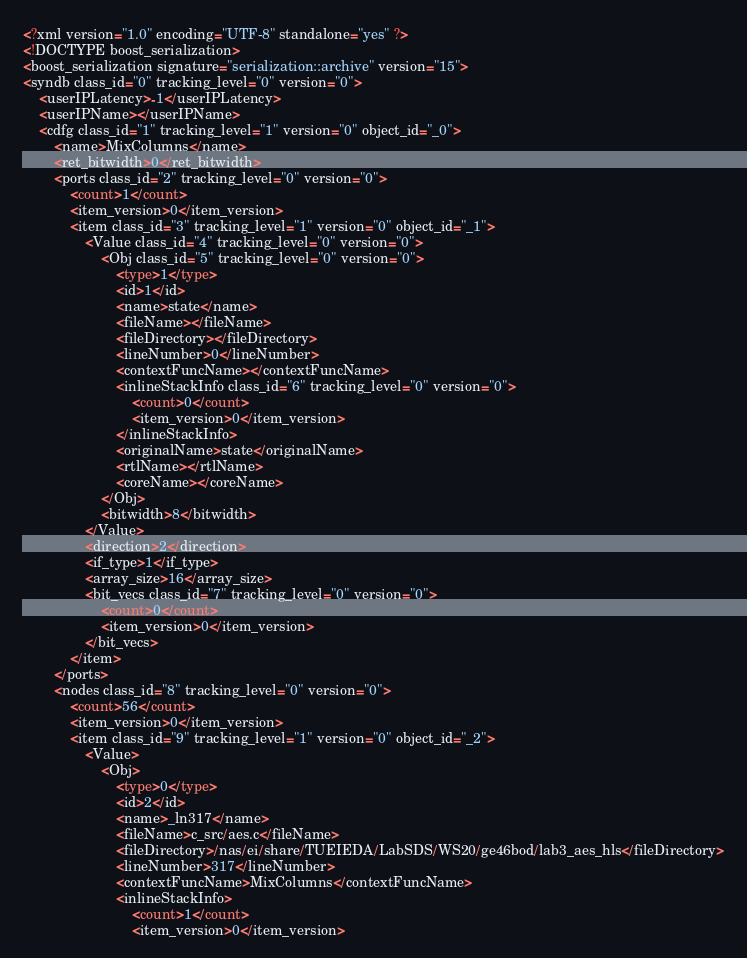Convert code to text. <code><loc_0><loc_0><loc_500><loc_500><_Ada_><?xml version="1.0" encoding="UTF-8" standalone="yes" ?>
<!DOCTYPE boost_serialization>
<boost_serialization signature="serialization::archive" version="15">
<syndb class_id="0" tracking_level="0" version="0">
	<userIPLatency>-1</userIPLatency>
	<userIPName></userIPName>
	<cdfg class_id="1" tracking_level="1" version="0" object_id="_0">
		<name>MixColumns</name>
		<ret_bitwidth>0</ret_bitwidth>
		<ports class_id="2" tracking_level="0" version="0">
			<count>1</count>
			<item_version>0</item_version>
			<item class_id="3" tracking_level="1" version="0" object_id="_1">
				<Value class_id="4" tracking_level="0" version="0">
					<Obj class_id="5" tracking_level="0" version="0">
						<type>1</type>
						<id>1</id>
						<name>state</name>
						<fileName></fileName>
						<fileDirectory></fileDirectory>
						<lineNumber>0</lineNumber>
						<contextFuncName></contextFuncName>
						<inlineStackInfo class_id="6" tracking_level="0" version="0">
							<count>0</count>
							<item_version>0</item_version>
						</inlineStackInfo>
						<originalName>state</originalName>
						<rtlName></rtlName>
						<coreName></coreName>
					</Obj>
					<bitwidth>8</bitwidth>
				</Value>
				<direction>2</direction>
				<if_type>1</if_type>
				<array_size>16</array_size>
				<bit_vecs class_id="7" tracking_level="0" version="0">
					<count>0</count>
					<item_version>0</item_version>
				</bit_vecs>
			</item>
		</ports>
		<nodes class_id="8" tracking_level="0" version="0">
			<count>56</count>
			<item_version>0</item_version>
			<item class_id="9" tracking_level="1" version="0" object_id="_2">
				<Value>
					<Obj>
						<type>0</type>
						<id>2</id>
						<name>_ln317</name>
						<fileName>c_src/aes.c</fileName>
						<fileDirectory>/nas/ei/share/TUEIEDA/LabSDS/WS20/ge46bod/lab3_aes_hls</fileDirectory>
						<lineNumber>317</lineNumber>
						<contextFuncName>MixColumns</contextFuncName>
						<inlineStackInfo>
							<count>1</count>
							<item_version>0</item_version></code> 